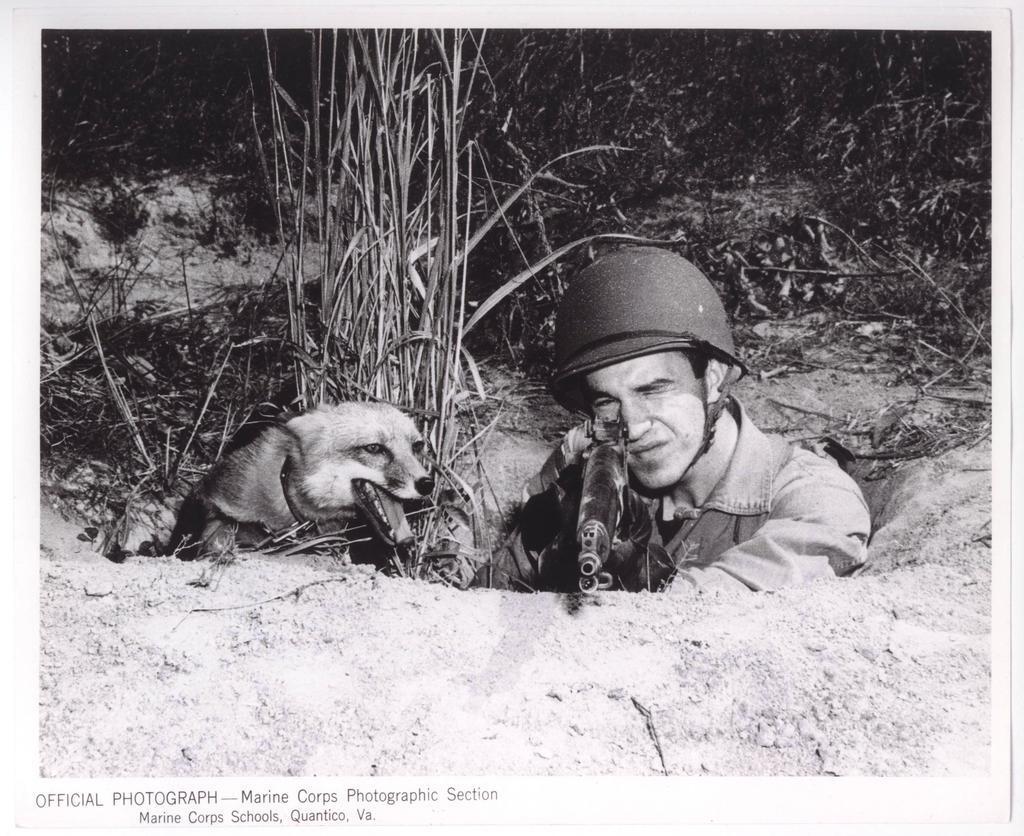In one or two sentences, can you explain what this image depicts? In this picture I can see a man and a dog in front and I see that the man is holding a gun and is wearing a helmet on his head and they're in a pit. In the background I can see the plants. On the bottom left of this image I see few words written and I see that this is a white and black image. 